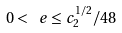<formula> <loc_0><loc_0><loc_500><loc_500>0 < \ e \leq c _ { 2 } ^ { 1 / 2 } / 4 8</formula> 